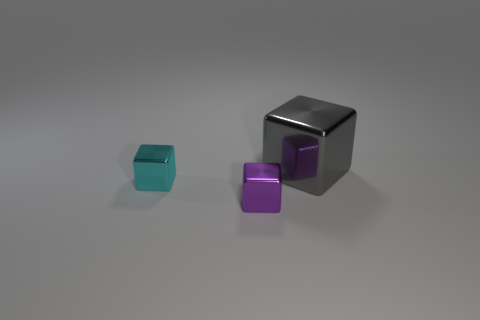There is a shiny cube that is in front of the cyan block; does it have the same size as the tiny cyan metallic object?
Your answer should be very brief. Yes. How many blocks are both behind the cyan thing and in front of the cyan shiny object?
Your response must be concise. 0. How big is the object right of the tiny cube in front of the small cyan cube?
Your answer should be very brief. Large. Is the number of cyan metal cubes that are to the right of the tiny cyan shiny block less than the number of blocks right of the small purple shiny cube?
Give a very brief answer. Yes. What is the block that is to the right of the cyan metallic block and behind the purple object made of?
Provide a short and direct response. Metal. Are any purple rubber cylinders visible?
Provide a short and direct response. No. What is the shape of the purple object that is made of the same material as the big gray object?
Give a very brief answer. Cube. There is a gray object; does it have the same shape as the thing that is on the left side of the purple object?
Offer a very short reply. Yes. There is a small object in front of the object left of the tiny purple metal block; what is its material?
Provide a short and direct response. Metal. What number of other objects are there of the same shape as the gray metal object?
Provide a succinct answer. 2. 